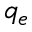Convert formula to latex. <formula><loc_0><loc_0><loc_500><loc_500>q _ { e }</formula> 